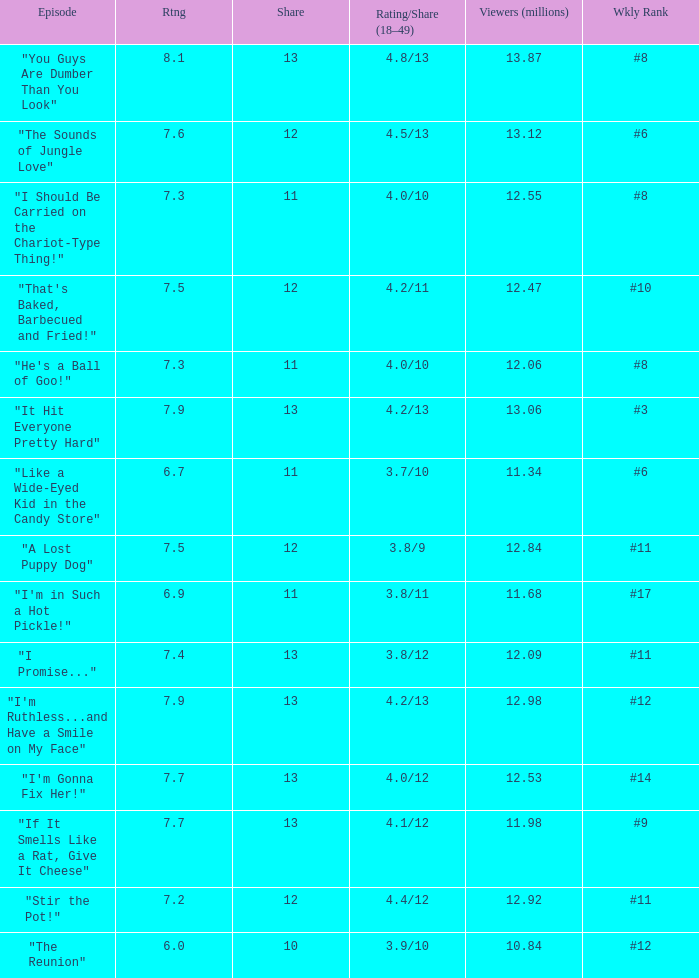What is the average rating for "a lost puppy dog"? 7.5. I'm looking to parse the entire table for insights. Could you assist me with that? {'header': ['Episode', 'Rtng', 'Share', 'Rating/Share (18–49)', 'Viewers (millions)', 'Wkly Rank'], 'rows': [['"You Guys Are Dumber Than You Look"', '8.1', '13', '4.8/13', '13.87', '#8'], ['"The Sounds of Jungle Love"', '7.6', '12', '4.5/13', '13.12', '#6'], ['"I Should Be Carried on the Chariot-Type Thing!"', '7.3', '11', '4.0/10', '12.55', '#8'], ['"That\'s Baked, Barbecued and Fried!"', '7.5', '12', '4.2/11', '12.47', '#10'], ['"He\'s a Ball of Goo!"', '7.3', '11', '4.0/10', '12.06', '#8'], ['"It Hit Everyone Pretty Hard"', '7.9', '13', '4.2/13', '13.06', '#3'], ['"Like a Wide-Eyed Kid in the Candy Store"', '6.7', '11', '3.7/10', '11.34', '#6'], ['"A Lost Puppy Dog"', '7.5', '12', '3.8/9', '12.84', '#11'], ['"I\'m in Such a Hot Pickle!"', '6.9', '11', '3.8/11', '11.68', '#17'], ['"I Promise..."', '7.4', '13', '3.8/12', '12.09', '#11'], ['"I\'m Ruthless...and Have a Smile on My Face"', '7.9', '13', '4.2/13', '12.98', '#12'], ['"I\'m Gonna Fix Her!"', '7.7', '13', '4.0/12', '12.53', '#14'], ['"If It Smells Like a Rat, Give It Cheese"', '7.7', '13', '4.1/12', '11.98', '#9'], ['"Stir the Pot!"', '7.2', '12', '4.4/12', '12.92', '#11'], ['"The Reunion"', '6.0', '10', '3.9/10', '10.84', '#12']]} 